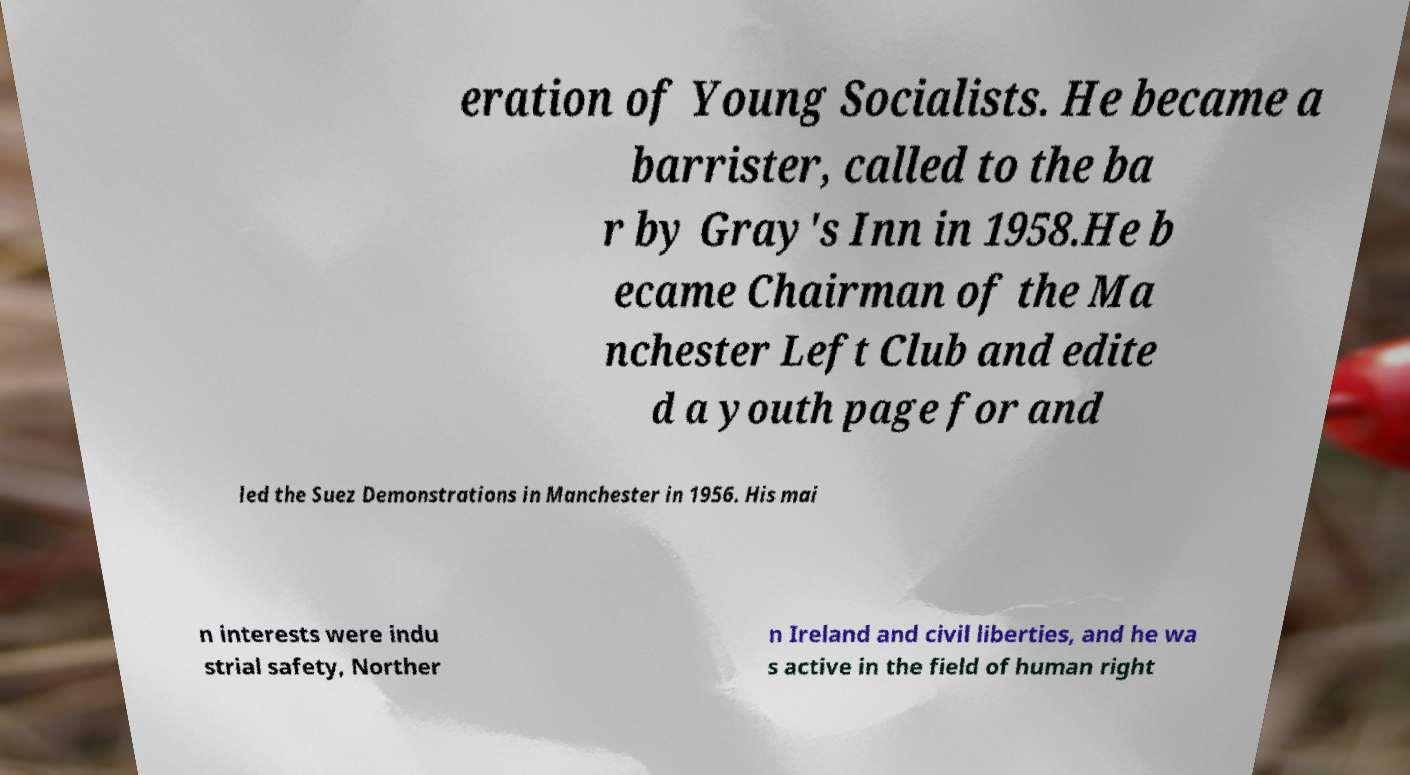For documentation purposes, I need the text within this image transcribed. Could you provide that? eration of Young Socialists. He became a barrister, called to the ba r by Gray's Inn in 1958.He b ecame Chairman of the Ma nchester Left Club and edite d a youth page for and led the Suez Demonstrations in Manchester in 1956. His mai n interests were indu strial safety, Norther n Ireland and civil liberties, and he wa s active in the field of human right 